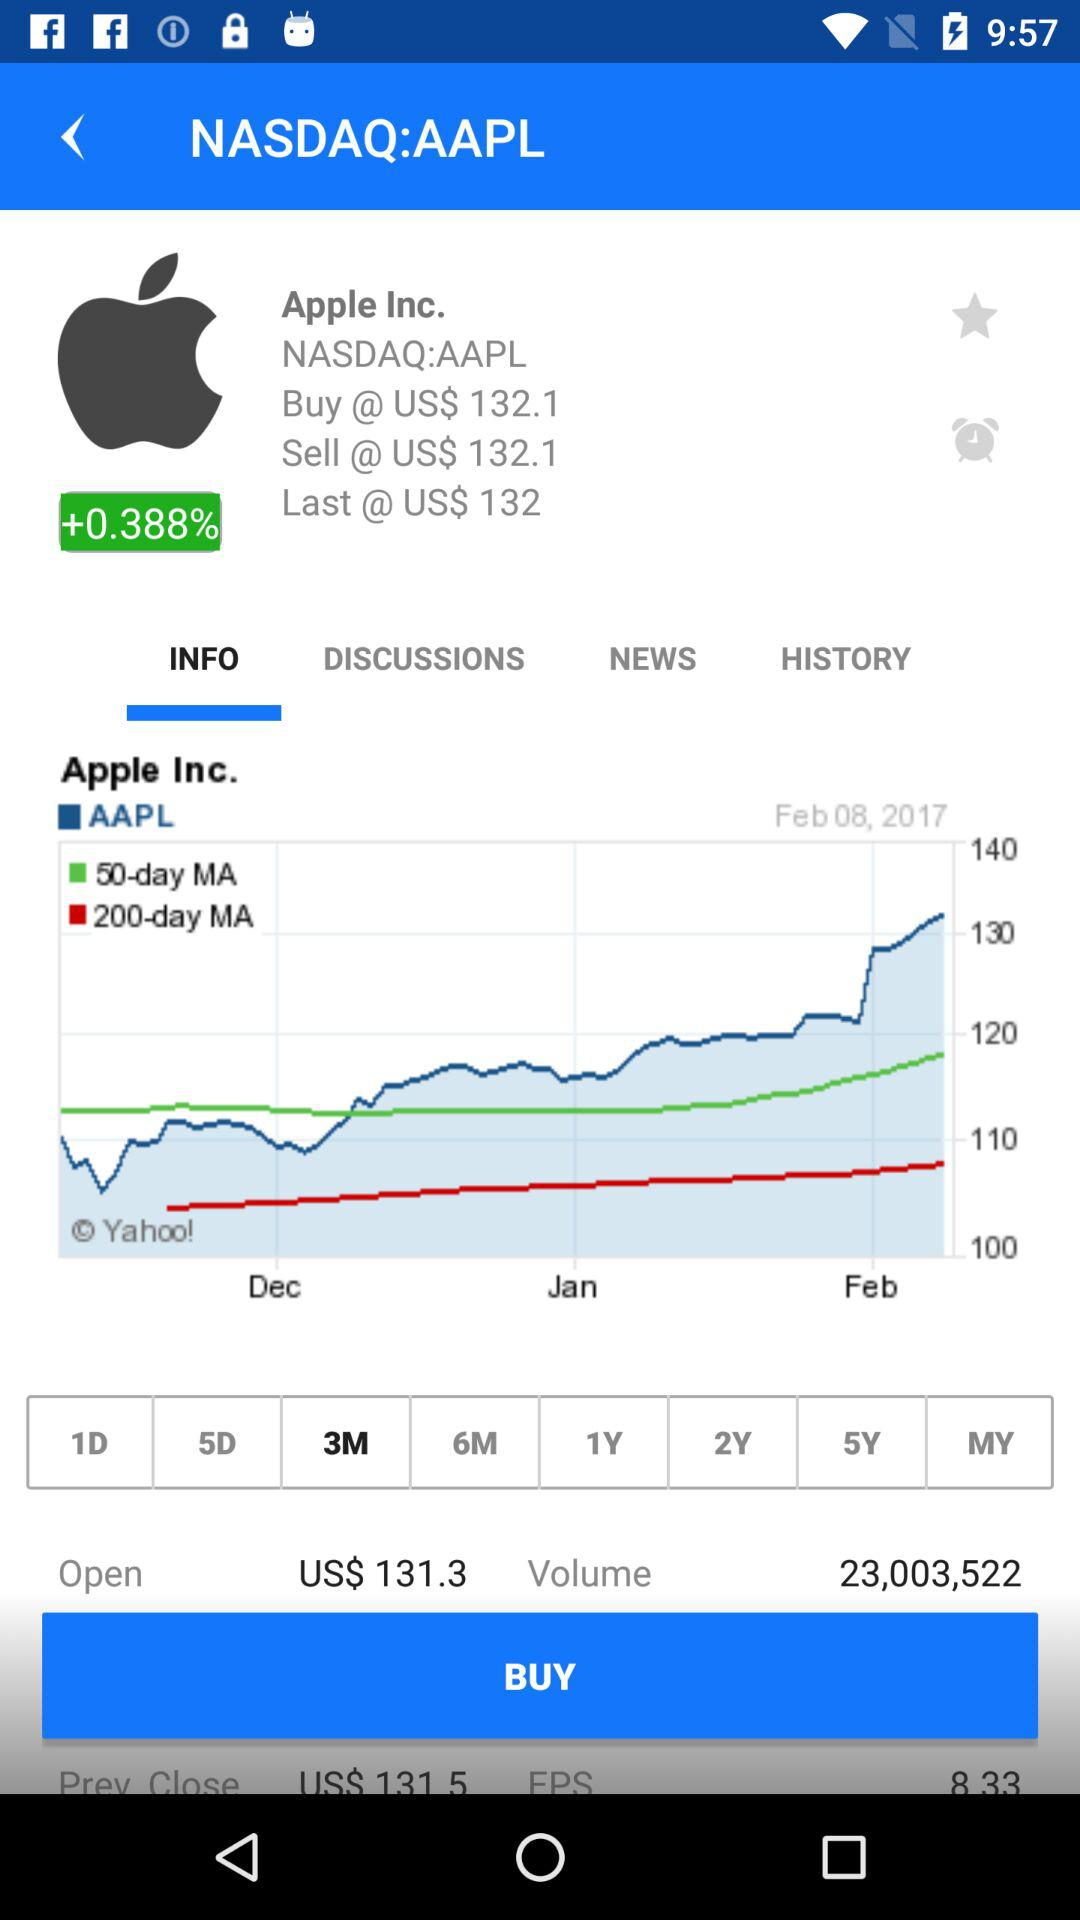Which 3 months does the graph show? The 3 months are December, January and February. 